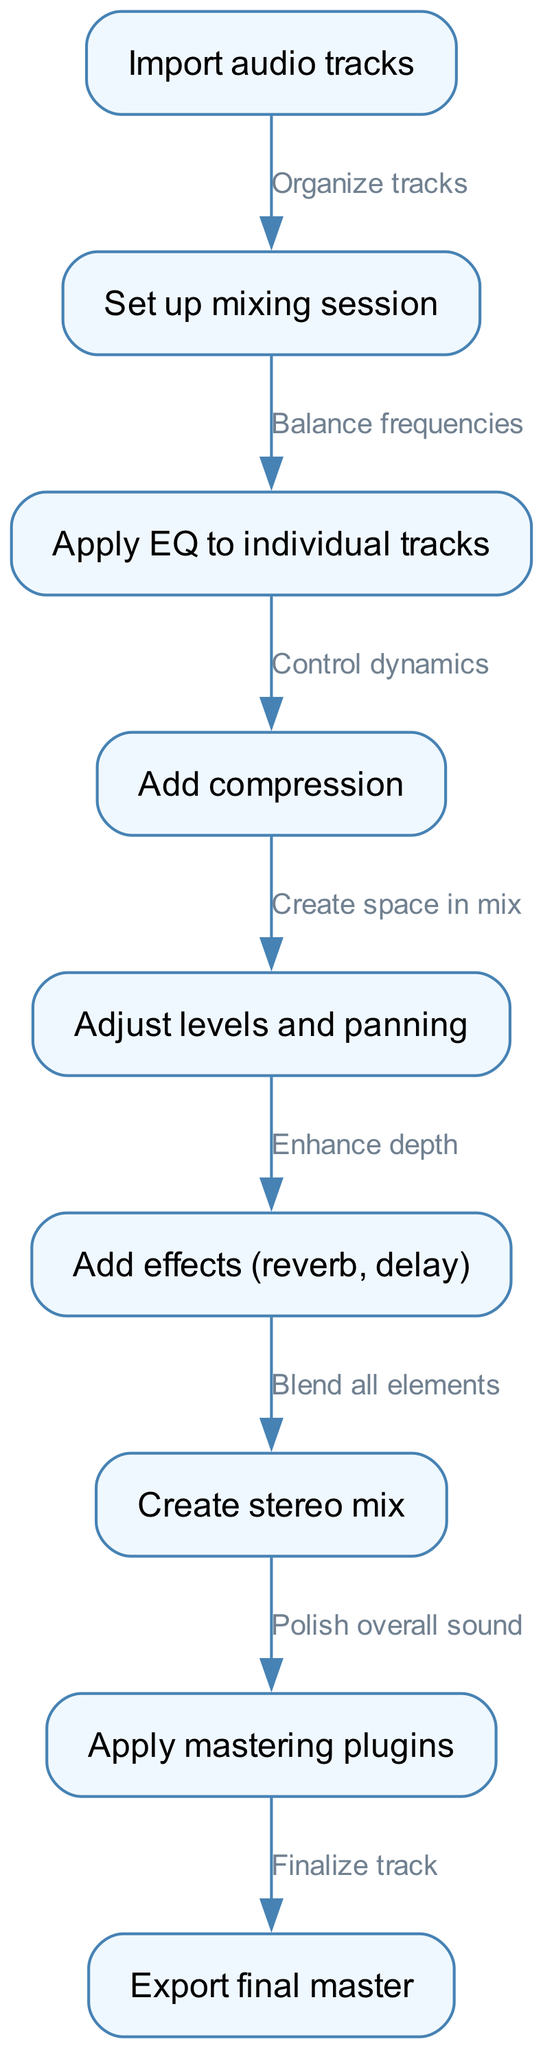What is the first step in the mixing process? The first node in the diagram states "Import audio tracks," which indicates the starting point of the mixing process.
Answer: Import audio tracks How many nodes are in the diagram? By counting each visual representation of a task, we find that there are nine nodes labeled from "Import audio tracks" through to "Export final master."
Answer: Nine What is the last step before exporting the final master? The diagram shows that the step before exporting the final master is "Apply mastering plugins," which is the second to last node.
Answer: Apply mastering plugins What relationship exists between applying EQ and adding compression? The edge connecting these two nodes indicates that you "Control dynamics" after applying EQ, showing a sequential process where compression enhances the overall dynamics of the mix set by the EQ.
Answer: Control dynamics What step enhances the depth of the mix? The diagram specifies "Add effects (reverb, delay)" as the key action taken after adjusting levels and panning, to enhance the depth of the mix.
Answer: Add effects (reverb, delay) What do you do after creating the stereo mix? Following the creation of a stereo mix, the next action is to "Apply mastering plugins," highlighting that mastering comes after mixing.
Answer: Apply mastering plugins Which two steps lead you to create a stereo mix? First, you "Add effects (reverb, delay)" to enhance depth, and then you "Blend all elements," which culminates in creating the stereo mix. This shows a connection of processes leading into the stereo mix step.
Answer: Add effects (reverb, delay) and Blend all elements What is the purpose of the step labeled "Adjust levels and panning"? The diagram explains that this step serves to "Create space in mix," showing its importance for sound clarity and separation in the overall balance of the tracks.
Answer: Create space in mix What is the key action to be performed after applying compression? After applying compression, the next action is to "Adjust levels and panning," which is crucial for balancing each track in the mix.
Answer: Adjust levels and panning 